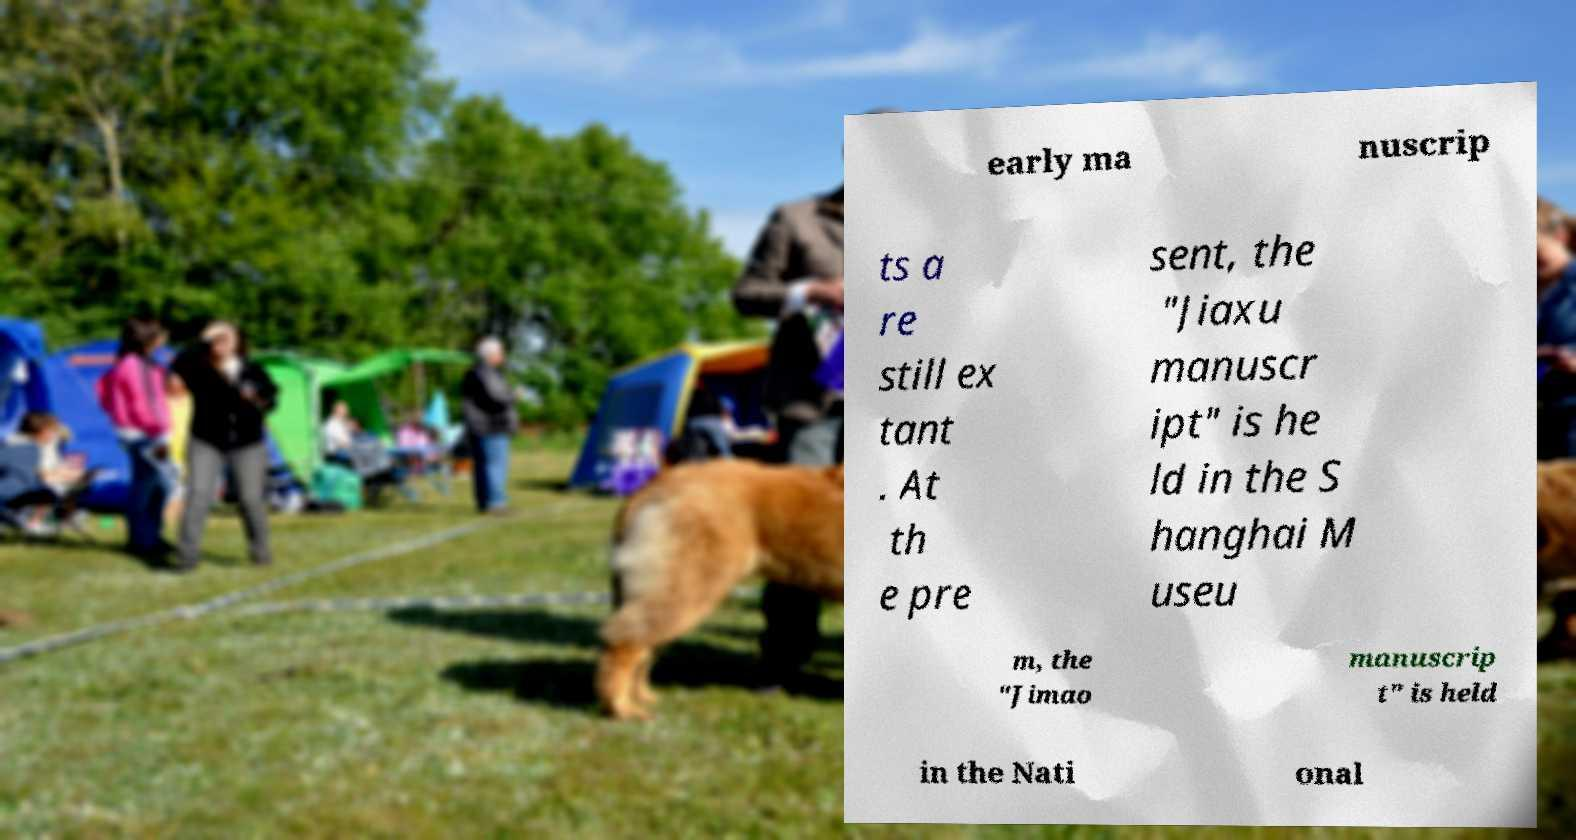What messages or text are displayed in this image? I need them in a readable, typed format. early ma nuscrip ts a re still ex tant . At th e pre sent, the "Jiaxu manuscr ipt" is he ld in the S hanghai M useu m, the "Jimao manuscrip t" is held in the Nati onal 